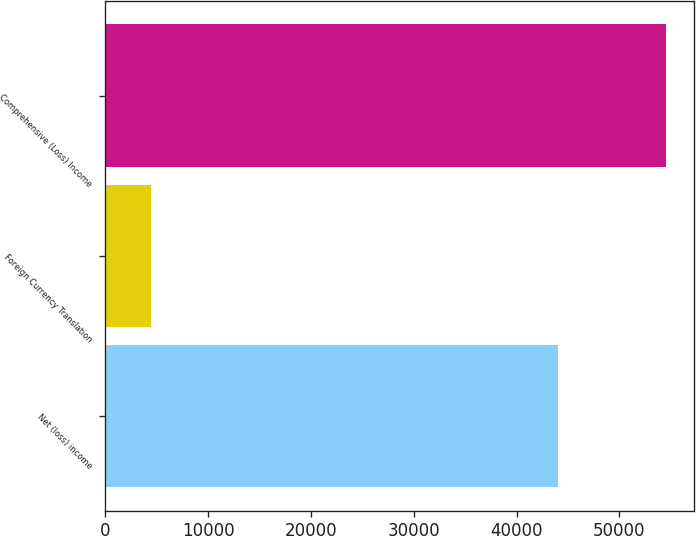Convert chart. <chart><loc_0><loc_0><loc_500><loc_500><bar_chart><fcel>Net (loss) income<fcel>Foreign Currency Translation<fcel>Comprehensive (Loss) Income<nl><fcel>44057<fcel>4388<fcel>54516<nl></chart> 